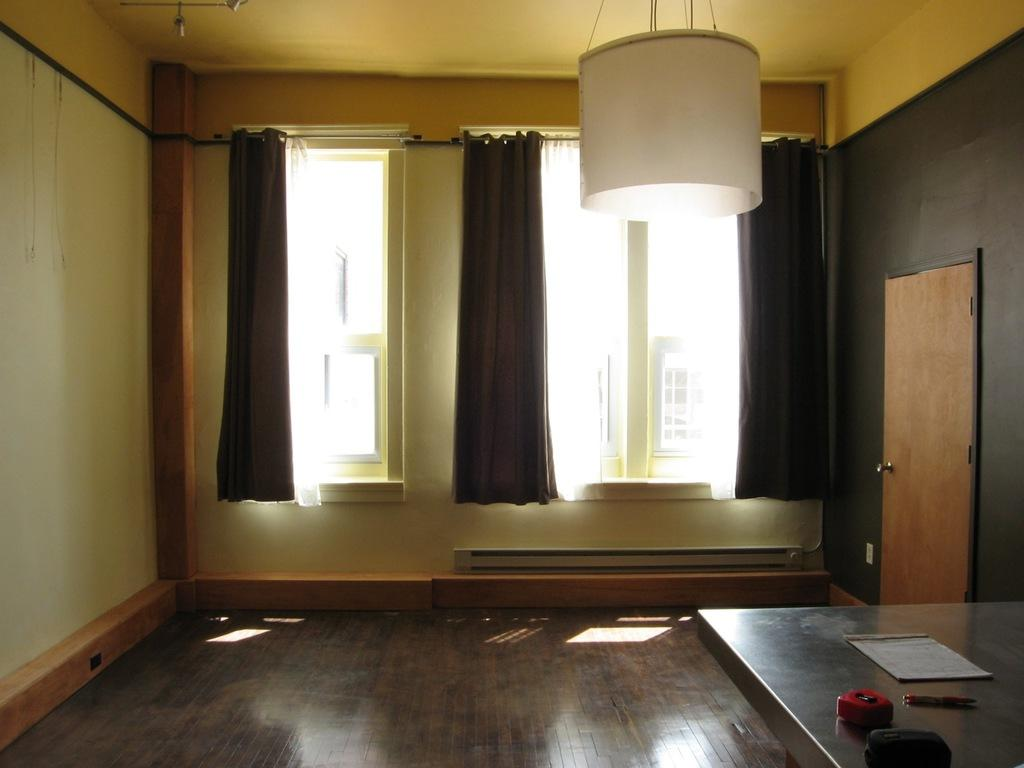What type of space is depicted in the image? There is a room in the image. What piece of furniture can be seen in the room? There is a table in the room. What is on the table in the image? There are things placed on the table, including a lamp. How many windows are in the room? There are two windows in the room. What is associated with the windows? There are curtains associated with the windows. Is there a way to enter or exit the room? Yes, there is a door in the room. What type of jam is being invented in the room? There is no mention of jam or any invention in the image; it simply shows a room with a table, a lamp, windows, curtains, and a door. 